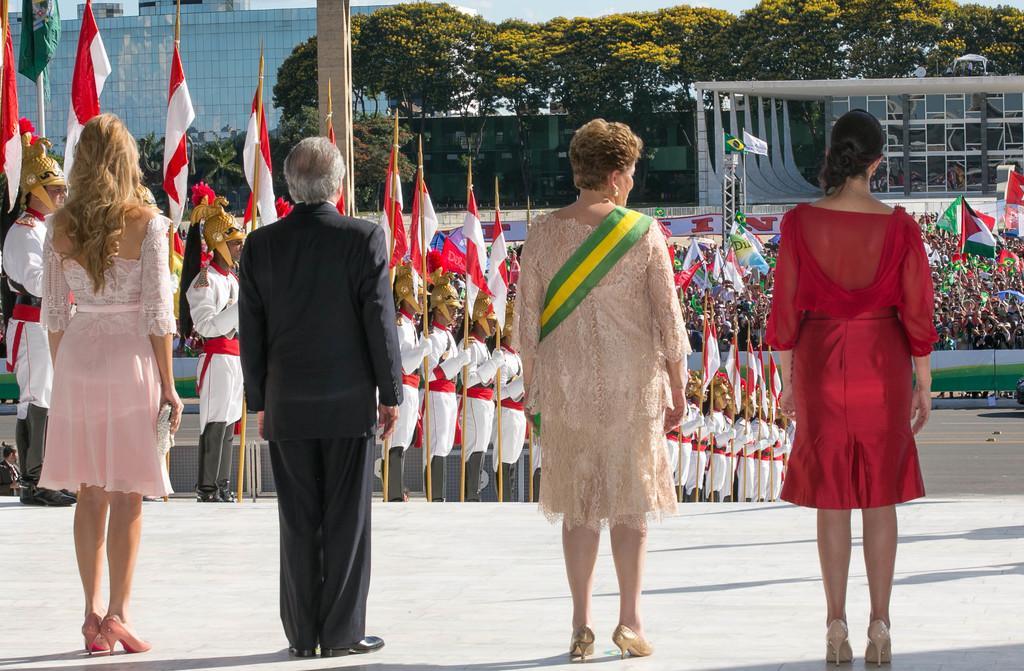How would you summarize this image in a sentence or two? This image consists of four people standing in the front. In the background, we can see many people standing and holding the flags. On the right, we can see a huge crowd. At the bottom, there is a road. In the background, there are many trees and a building. 